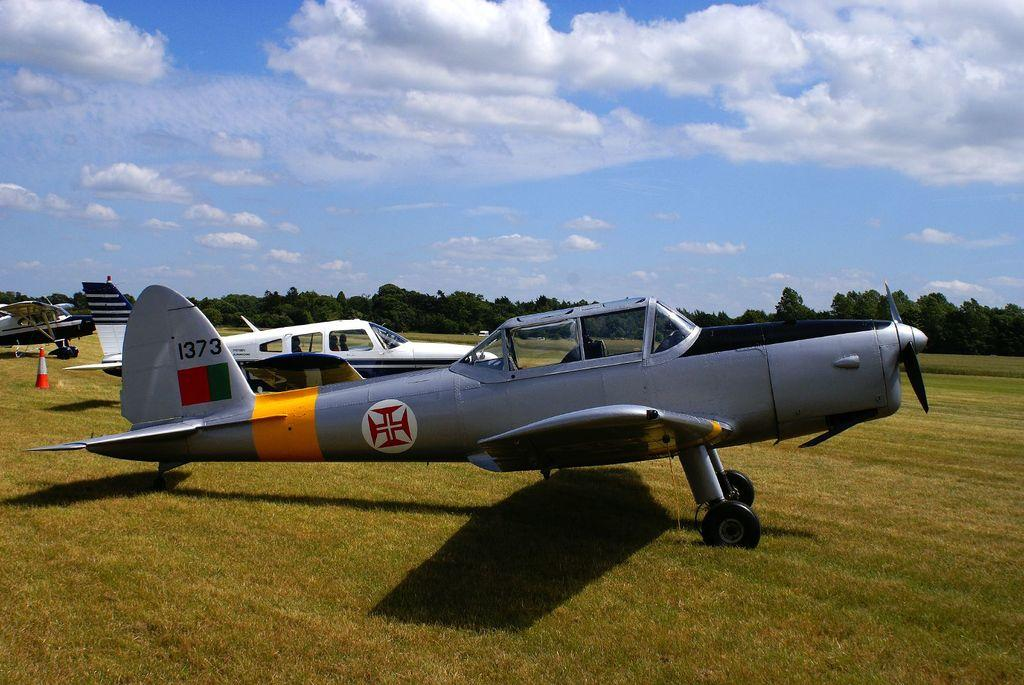<image>
Present a compact description of the photo's key features. Grey propeller war plane with a German cross insignia plus the unit number 1373 on the body. 